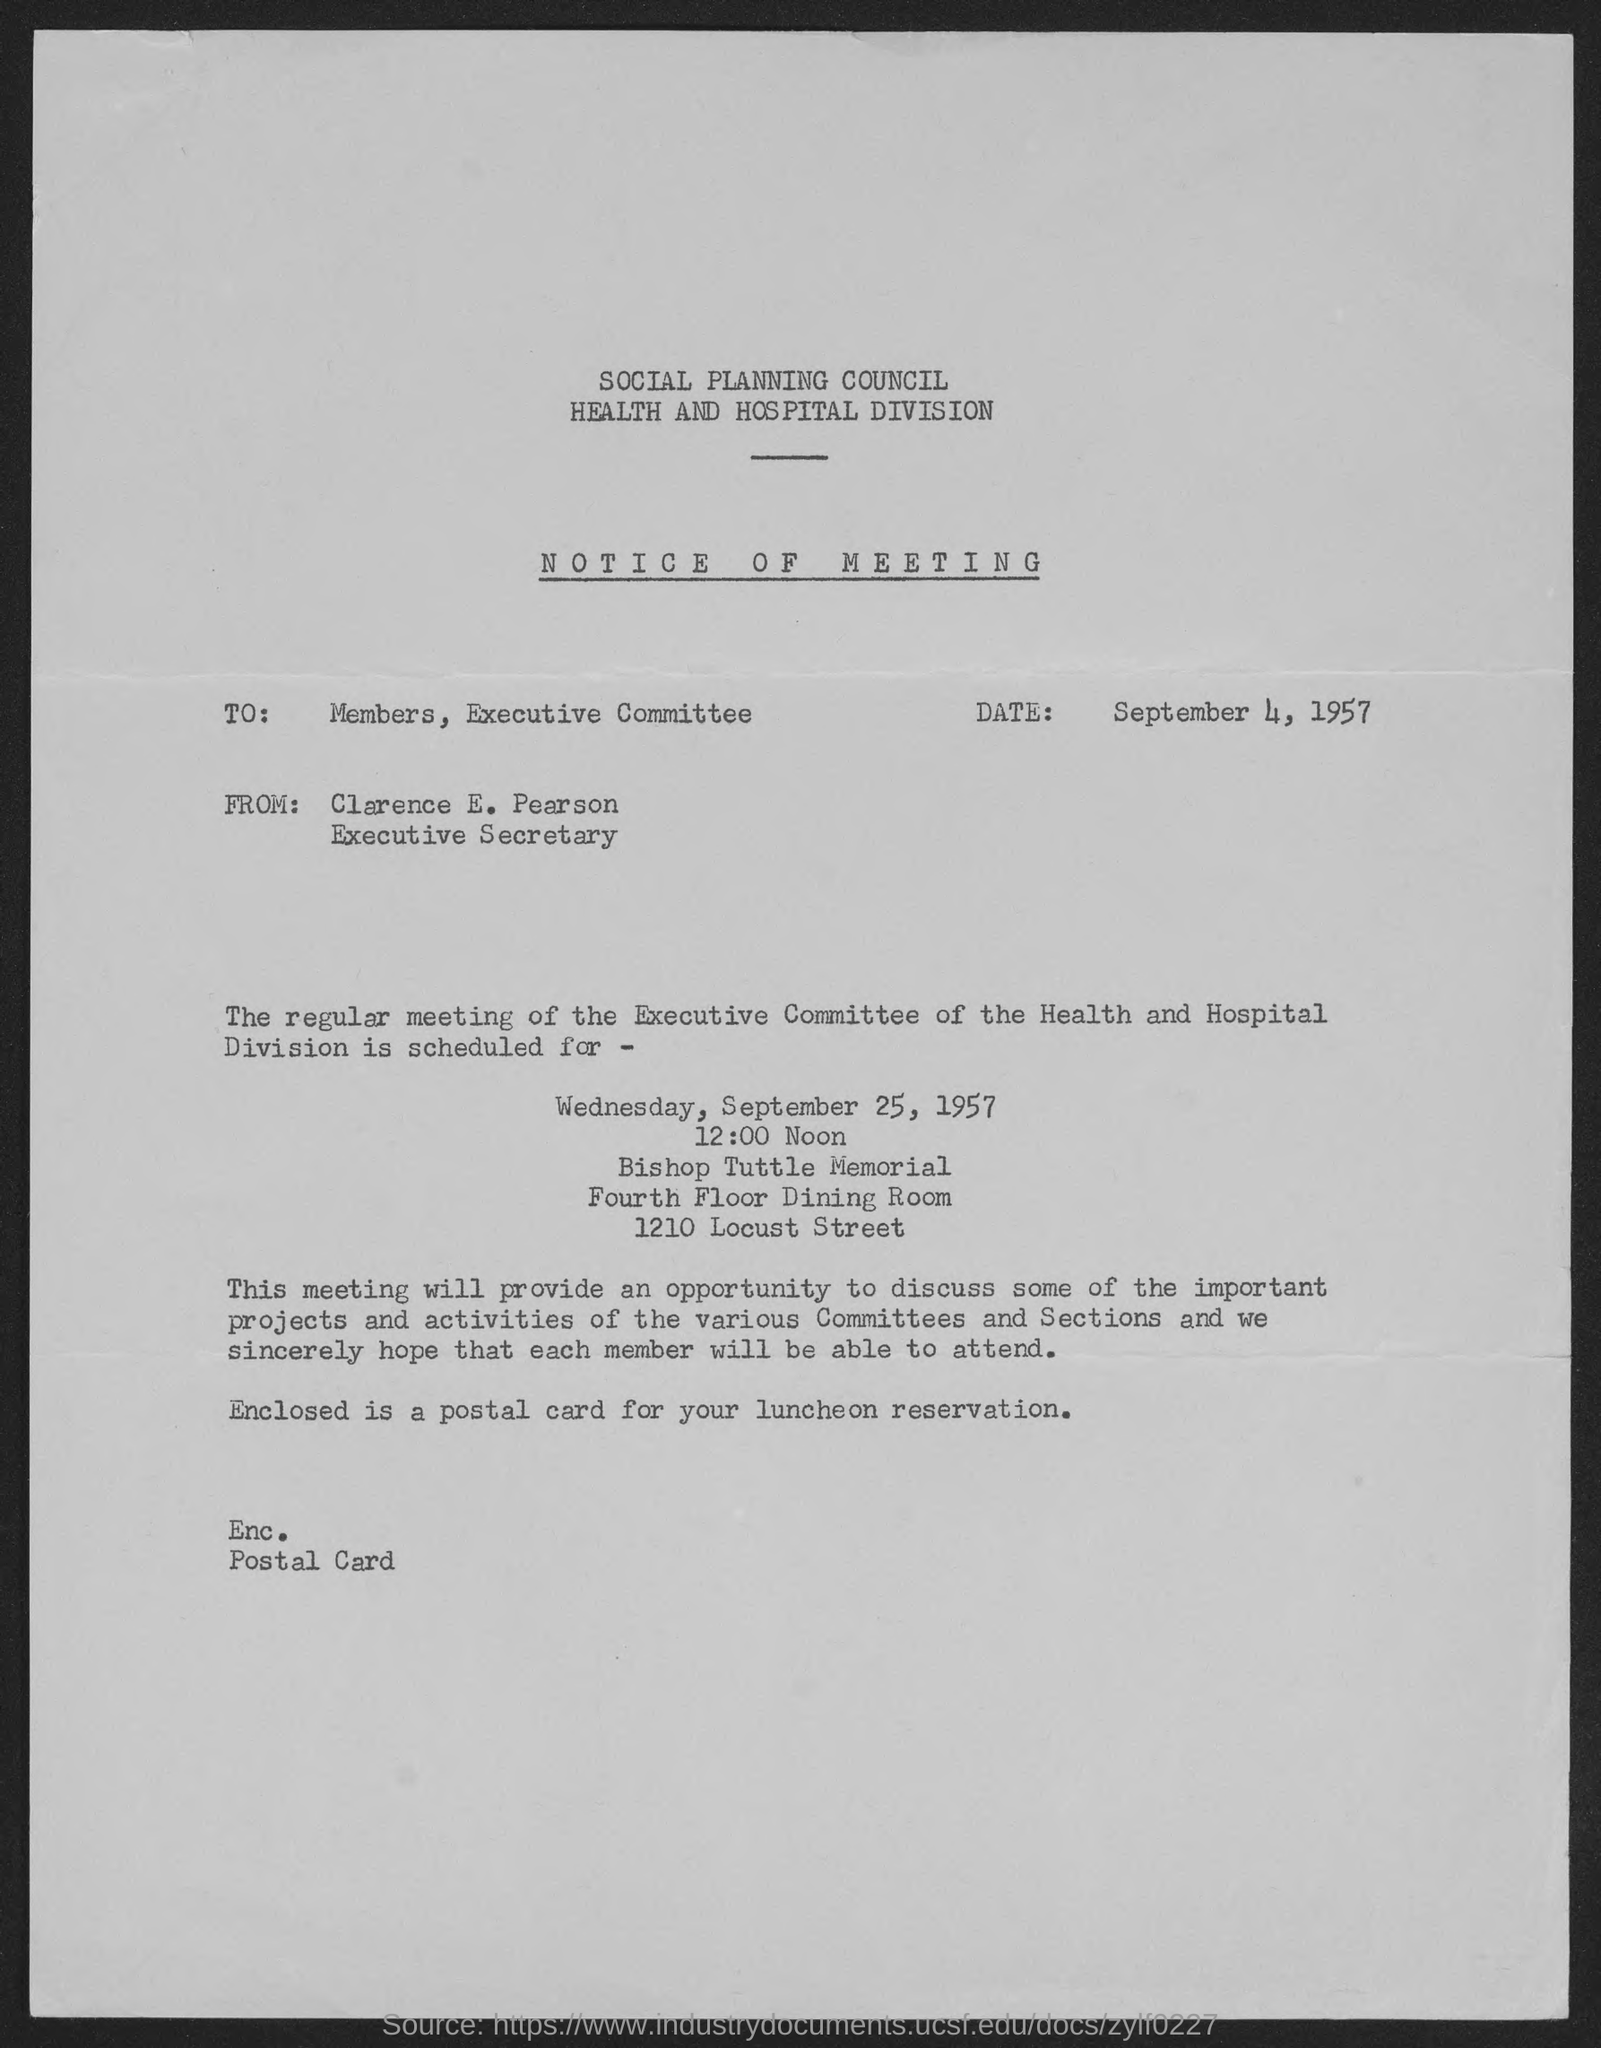When is the notice dated on?
Give a very brief answer. September 4, 1957. What is the position of clarence e. pearson ?
Offer a terse response. Executive Secretary. From whom is notice of meeting from?
Provide a succinct answer. Clarence E. Pearson. To whom is this notice written to?
Your answer should be very brief. Members. On what date is the regular meeting of the executive committee of the health and hospital division scheduled  ?
Your answer should be very brief. September 25, 1957. What day of the week is the meeting scheduled on?
Your answer should be very brief. Wednesday. What time is the regular meeting of the executive committee of the health and hospitals  scheduled ?
Your answer should be very brief. 12:00 Noon. What is the street address of bishop tuttle memorial ?
Provide a short and direct response. 1210 Locust Street. What is the venue for regular meeting of the executive committee of health and hospitals is scheduled at ?
Provide a succinct answer. Bishop Tuttle Memorial. 